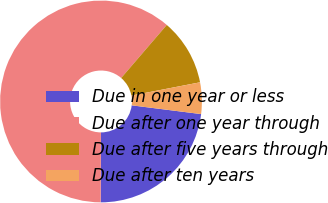<chart> <loc_0><loc_0><loc_500><loc_500><pie_chart><fcel>Due in one year or less<fcel>Due after one year through<fcel>Due after five years through<fcel>Due after ten years<nl><fcel>23.06%<fcel>61.25%<fcel>10.66%<fcel>5.04%<nl></chart> 